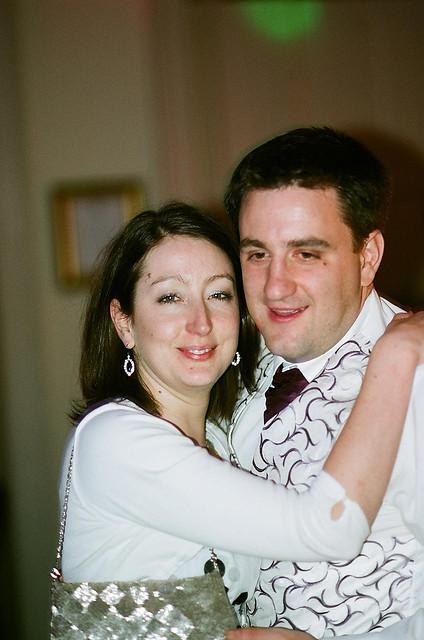Are these people happy?
Answer briefly. Yes. What is bright green in the background?
Quick response, please. Light. What is around the man's neck?
Answer briefly. Tie. Is the girl wearing glasses?
Keep it brief. No. Is the person in this photo wearing earrings?
Be succinct. Yes. Is she wearing earrings?
Write a very short answer. Yes. What is this woman wearing on her wrist?
Keep it brief. Nothing. How is she holding her arms?
Concise answer only. Around his neck. What is the woman's hairstyle?
Answer briefly. Bob. 